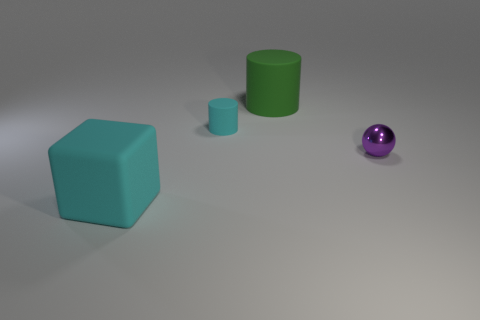Add 3 large green cylinders. How many objects exist? 7 Subtract all green cylinders. How many cylinders are left? 1 Subtract all red spheres. How many green cylinders are left? 1 Subtract all small brown metallic cubes. Subtract all tiny purple shiny things. How many objects are left? 3 Add 3 cyan cylinders. How many cyan cylinders are left? 4 Add 4 large matte objects. How many large matte objects exist? 6 Subtract 0 red cylinders. How many objects are left? 4 Subtract all red spheres. Subtract all cyan cubes. How many spheres are left? 1 